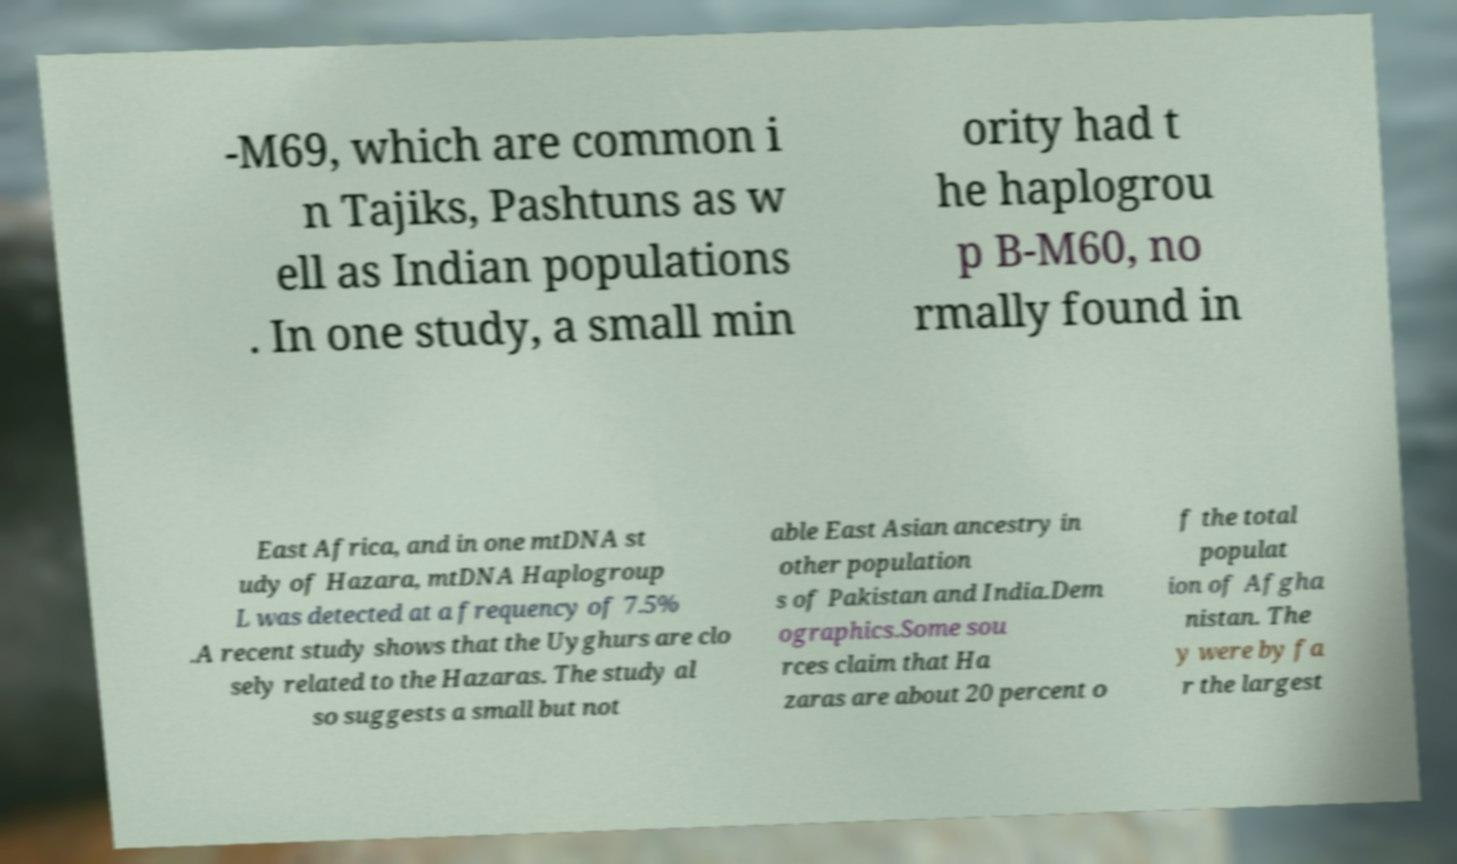I need the written content from this picture converted into text. Can you do that? -M69, which are common i n Tajiks, Pashtuns as w ell as Indian populations . In one study, a small min ority had t he haplogrou p B-M60, no rmally found in East Africa, and in one mtDNA st udy of Hazara, mtDNA Haplogroup L was detected at a frequency of 7.5% .A recent study shows that the Uyghurs are clo sely related to the Hazaras. The study al so suggests a small but not able East Asian ancestry in other population s of Pakistan and India.Dem ographics.Some sou rces claim that Ha zaras are about 20 percent o f the total populat ion of Afgha nistan. The y were by fa r the largest 